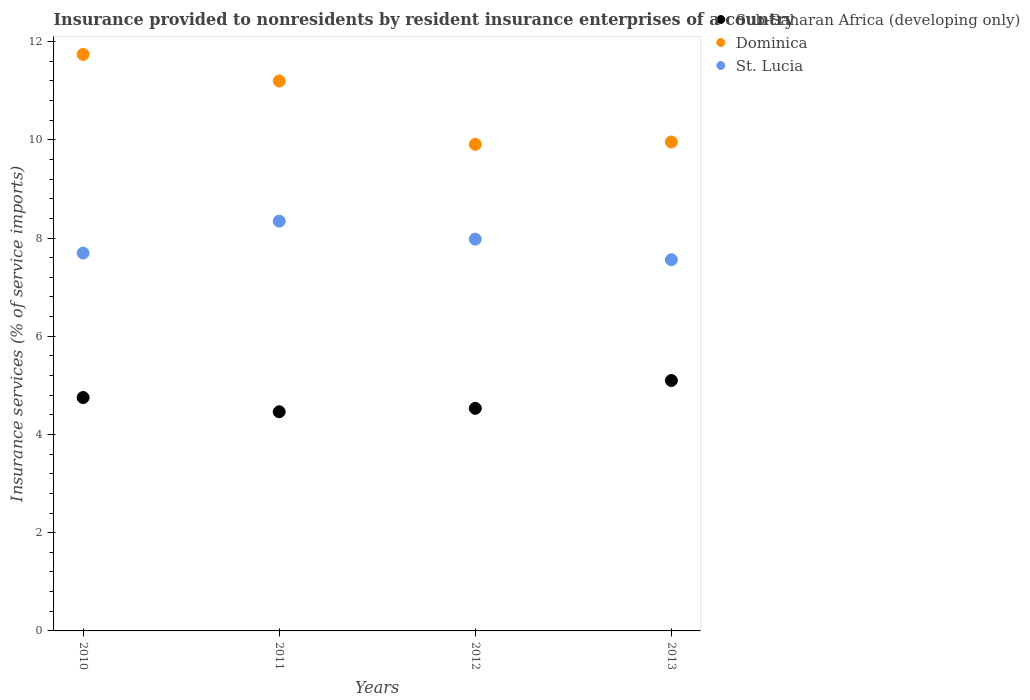How many different coloured dotlines are there?
Offer a terse response. 3. Is the number of dotlines equal to the number of legend labels?
Give a very brief answer. Yes. What is the insurance provided to nonresidents in Dominica in 2010?
Ensure brevity in your answer.  11.74. Across all years, what is the maximum insurance provided to nonresidents in Dominica?
Ensure brevity in your answer.  11.74. Across all years, what is the minimum insurance provided to nonresidents in Sub-Saharan Africa (developing only)?
Keep it short and to the point. 4.46. In which year was the insurance provided to nonresidents in Sub-Saharan Africa (developing only) maximum?
Ensure brevity in your answer.  2013. In which year was the insurance provided to nonresidents in St. Lucia minimum?
Make the answer very short. 2013. What is the total insurance provided to nonresidents in St. Lucia in the graph?
Keep it short and to the point. 31.57. What is the difference between the insurance provided to nonresidents in Dominica in 2011 and that in 2013?
Your answer should be very brief. 1.24. What is the difference between the insurance provided to nonresidents in Sub-Saharan Africa (developing only) in 2011 and the insurance provided to nonresidents in St. Lucia in 2010?
Offer a very short reply. -3.23. What is the average insurance provided to nonresidents in Dominica per year?
Ensure brevity in your answer.  10.7. In the year 2013, what is the difference between the insurance provided to nonresidents in Dominica and insurance provided to nonresidents in Sub-Saharan Africa (developing only)?
Make the answer very short. 4.86. In how many years, is the insurance provided to nonresidents in Dominica greater than 6.8 %?
Your answer should be very brief. 4. What is the ratio of the insurance provided to nonresidents in Dominica in 2012 to that in 2013?
Give a very brief answer. 1. Is the insurance provided to nonresidents in Dominica in 2011 less than that in 2013?
Ensure brevity in your answer.  No. What is the difference between the highest and the second highest insurance provided to nonresidents in Sub-Saharan Africa (developing only)?
Offer a terse response. 0.35. What is the difference between the highest and the lowest insurance provided to nonresidents in Dominica?
Your response must be concise. 1.83. Is the insurance provided to nonresidents in Sub-Saharan Africa (developing only) strictly less than the insurance provided to nonresidents in Dominica over the years?
Offer a very short reply. Yes. What is the difference between two consecutive major ticks on the Y-axis?
Keep it short and to the point. 2. Does the graph contain any zero values?
Provide a short and direct response. No. Does the graph contain grids?
Ensure brevity in your answer.  No. Where does the legend appear in the graph?
Provide a succinct answer. Top right. What is the title of the graph?
Make the answer very short. Insurance provided to nonresidents by resident insurance enterprises of a country. What is the label or title of the Y-axis?
Your answer should be compact. Insurance services (% of service imports). What is the Insurance services (% of service imports) of Sub-Saharan Africa (developing only) in 2010?
Offer a terse response. 4.75. What is the Insurance services (% of service imports) of Dominica in 2010?
Give a very brief answer. 11.74. What is the Insurance services (% of service imports) in St. Lucia in 2010?
Your answer should be very brief. 7.69. What is the Insurance services (% of service imports) of Sub-Saharan Africa (developing only) in 2011?
Offer a very short reply. 4.46. What is the Insurance services (% of service imports) of Dominica in 2011?
Provide a succinct answer. 11.2. What is the Insurance services (% of service imports) in St. Lucia in 2011?
Ensure brevity in your answer.  8.34. What is the Insurance services (% of service imports) in Sub-Saharan Africa (developing only) in 2012?
Provide a succinct answer. 4.53. What is the Insurance services (% of service imports) in Dominica in 2012?
Make the answer very short. 9.91. What is the Insurance services (% of service imports) in St. Lucia in 2012?
Keep it short and to the point. 7.98. What is the Insurance services (% of service imports) of Sub-Saharan Africa (developing only) in 2013?
Your answer should be compact. 5.1. What is the Insurance services (% of service imports) in Dominica in 2013?
Provide a short and direct response. 9.96. What is the Insurance services (% of service imports) of St. Lucia in 2013?
Ensure brevity in your answer.  7.56. Across all years, what is the maximum Insurance services (% of service imports) of Sub-Saharan Africa (developing only)?
Offer a very short reply. 5.1. Across all years, what is the maximum Insurance services (% of service imports) in Dominica?
Your answer should be very brief. 11.74. Across all years, what is the maximum Insurance services (% of service imports) of St. Lucia?
Ensure brevity in your answer.  8.34. Across all years, what is the minimum Insurance services (% of service imports) of Sub-Saharan Africa (developing only)?
Keep it short and to the point. 4.46. Across all years, what is the minimum Insurance services (% of service imports) in Dominica?
Make the answer very short. 9.91. Across all years, what is the minimum Insurance services (% of service imports) of St. Lucia?
Make the answer very short. 7.56. What is the total Insurance services (% of service imports) of Sub-Saharan Africa (developing only) in the graph?
Provide a short and direct response. 18.85. What is the total Insurance services (% of service imports) in Dominica in the graph?
Keep it short and to the point. 42.8. What is the total Insurance services (% of service imports) of St. Lucia in the graph?
Keep it short and to the point. 31.57. What is the difference between the Insurance services (% of service imports) of Sub-Saharan Africa (developing only) in 2010 and that in 2011?
Provide a succinct answer. 0.29. What is the difference between the Insurance services (% of service imports) in Dominica in 2010 and that in 2011?
Offer a terse response. 0.54. What is the difference between the Insurance services (% of service imports) of St. Lucia in 2010 and that in 2011?
Your answer should be compact. -0.65. What is the difference between the Insurance services (% of service imports) of Sub-Saharan Africa (developing only) in 2010 and that in 2012?
Provide a short and direct response. 0.22. What is the difference between the Insurance services (% of service imports) of Dominica in 2010 and that in 2012?
Offer a terse response. 1.83. What is the difference between the Insurance services (% of service imports) in St. Lucia in 2010 and that in 2012?
Provide a short and direct response. -0.28. What is the difference between the Insurance services (% of service imports) in Sub-Saharan Africa (developing only) in 2010 and that in 2013?
Provide a short and direct response. -0.35. What is the difference between the Insurance services (% of service imports) in Dominica in 2010 and that in 2013?
Provide a short and direct response. 1.78. What is the difference between the Insurance services (% of service imports) in St. Lucia in 2010 and that in 2013?
Provide a succinct answer. 0.14. What is the difference between the Insurance services (% of service imports) of Sub-Saharan Africa (developing only) in 2011 and that in 2012?
Make the answer very short. -0.07. What is the difference between the Insurance services (% of service imports) in Dominica in 2011 and that in 2012?
Offer a terse response. 1.29. What is the difference between the Insurance services (% of service imports) of St. Lucia in 2011 and that in 2012?
Provide a succinct answer. 0.37. What is the difference between the Insurance services (% of service imports) of Sub-Saharan Africa (developing only) in 2011 and that in 2013?
Your response must be concise. -0.64. What is the difference between the Insurance services (% of service imports) of Dominica in 2011 and that in 2013?
Offer a terse response. 1.24. What is the difference between the Insurance services (% of service imports) in St. Lucia in 2011 and that in 2013?
Offer a very short reply. 0.79. What is the difference between the Insurance services (% of service imports) in Sub-Saharan Africa (developing only) in 2012 and that in 2013?
Ensure brevity in your answer.  -0.57. What is the difference between the Insurance services (% of service imports) in Dominica in 2012 and that in 2013?
Your response must be concise. -0.05. What is the difference between the Insurance services (% of service imports) in St. Lucia in 2012 and that in 2013?
Offer a terse response. 0.42. What is the difference between the Insurance services (% of service imports) in Sub-Saharan Africa (developing only) in 2010 and the Insurance services (% of service imports) in Dominica in 2011?
Provide a succinct answer. -6.44. What is the difference between the Insurance services (% of service imports) in Sub-Saharan Africa (developing only) in 2010 and the Insurance services (% of service imports) in St. Lucia in 2011?
Offer a very short reply. -3.59. What is the difference between the Insurance services (% of service imports) in Dominica in 2010 and the Insurance services (% of service imports) in St. Lucia in 2011?
Ensure brevity in your answer.  3.39. What is the difference between the Insurance services (% of service imports) of Sub-Saharan Africa (developing only) in 2010 and the Insurance services (% of service imports) of Dominica in 2012?
Your response must be concise. -5.16. What is the difference between the Insurance services (% of service imports) in Sub-Saharan Africa (developing only) in 2010 and the Insurance services (% of service imports) in St. Lucia in 2012?
Offer a very short reply. -3.22. What is the difference between the Insurance services (% of service imports) in Dominica in 2010 and the Insurance services (% of service imports) in St. Lucia in 2012?
Provide a short and direct response. 3.76. What is the difference between the Insurance services (% of service imports) in Sub-Saharan Africa (developing only) in 2010 and the Insurance services (% of service imports) in Dominica in 2013?
Your answer should be very brief. -5.2. What is the difference between the Insurance services (% of service imports) of Sub-Saharan Africa (developing only) in 2010 and the Insurance services (% of service imports) of St. Lucia in 2013?
Your answer should be compact. -2.81. What is the difference between the Insurance services (% of service imports) in Dominica in 2010 and the Insurance services (% of service imports) in St. Lucia in 2013?
Offer a terse response. 4.18. What is the difference between the Insurance services (% of service imports) of Sub-Saharan Africa (developing only) in 2011 and the Insurance services (% of service imports) of Dominica in 2012?
Offer a terse response. -5.45. What is the difference between the Insurance services (% of service imports) in Sub-Saharan Africa (developing only) in 2011 and the Insurance services (% of service imports) in St. Lucia in 2012?
Your response must be concise. -3.51. What is the difference between the Insurance services (% of service imports) in Dominica in 2011 and the Insurance services (% of service imports) in St. Lucia in 2012?
Offer a terse response. 3.22. What is the difference between the Insurance services (% of service imports) in Sub-Saharan Africa (developing only) in 2011 and the Insurance services (% of service imports) in Dominica in 2013?
Make the answer very short. -5.49. What is the difference between the Insurance services (% of service imports) in Sub-Saharan Africa (developing only) in 2011 and the Insurance services (% of service imports) in St. Lucia in 2013?
Your answer should be very brief. -3.1. What is the difference between the Insurance services (% of service imports) in Dominica in 2011 and the Insurance services (% of service imports) in St. Lucia in 2013?
Give a very brief answer. 3.64. What is the difference between the Insurance services (% of service imports) of Sub-Saharan Africa (developing only) in 2012 and the Insurance services (% of service imports) of Dominica in 2013?
Ensure brevity in your answer.  -5.42. What is the difference between the Insurance services (% of service imports) of Sub-Saharan Africa (developing only) in 2012 and the Insurance services (% of service imports) of St. Lucia in 2013?
Provide a short and direct response. -3.03. What is the difference between the Insurance services (% of service imports) in Dominica in 2012 and the Insurance services (% of service imports) in St. Lucia in 2013?
Ensure brevity in your answer.  2.35. What is the average Insurance services (% of service imports) of Sub-Saharan Africa (developing only) per year?
Your answer should be very brief. 4.71. What is the average Insurance services (% of service imports) of Dominica per year?
Your answer should be compact. 10.7. What is the average Insurance services (% of service imports) of St. Lucia per year?
Ensure brevity in your answer.  7.89. In the year 2010, what is the difference between the Insurance services (% of service imports) in Sub-Saharan Africa (developing only) and Insurance services (% of service imports) in Dominica?
Provide a short and direct response. -6.99. In the year 2010, what is the difference between the Insurance services (% of service imports) of Sub-Saharan Africa (developing only) and Insurance services (% of service imports) of St. Lucia?
Keep it short and to the point. -2.94. In the year 2010, what is the difference between the Insurance services (% of service imports) in Dominica and Insurance services (% of service imports) in St. Lucia?
Your answer should be compact. 4.04. In the year 2011, what is the difference between the Insurance services (% of service imports) of Sub-Saharan Africa (developing only) and Insurance services (% of service imports) of Dominica?
Give a very brief answer. -6.73. In the year 2011, what is the difference between the Insurance services (% of service imports) of Sub-Saharan Africa (developing only) and Insurance services (% of service imports) of St. Lucia?
Your response must be concise. -3.88. In the year 2011, what is the difference between the Insurance services (% of service imports) of Dominica and Insurance services (% of service imports) of St. Lucia?
Keep it short and to the point. 2.85. In the year 2012, what is the difference between the Insurance services (% of service imports) of Sub-Saharan Africa (developing only) and Insurance services (% of service imports) of Dominica?
Give a very brief answer. -5.38. In the year 2012, what is the difference between the Insurance services (% of service imports) in Sub-Saharan Africa (developing only) and Insurance services (% of service imports) in St. Lucia?
Give a very brief answer. -3.44. In the year 2012, what is the difference between the Insurance services (% of service imports) in Dominica and Insurance services (% of service imports) in St. Lucia?
Make the answer very short. 1.93. In the year 2013, what is the difference between the Insurance services (% of service imports) of Sub-Saharan Africa (developing only) and Insurance services (% of service imports) of Dominica?
Provide a short and direct response. -4.86. In the year 2013, what is the difference between the Insurance services (% of service imports) in Sub-Saharan Africa (developing only) and Insurance services (% of service imports) in St. Lucia?
Make the answer very short. -2.46. In the year 2013, what is the difference between the Insurance services (% of service imports) in Dominica and Insurance services (% of service imports) in St. Lucia?
Provide a succinct answer. 2.4. What is the ratio of the Insurance services (% of service imports) of Sub-Saharan Africa (developing only) in 2010 to that in 2011?
Make the answer very short. 1.06. What is the ratio of the Insurance services (% of service imports) of Dominica in 2010 to that in 2011?
Your answer should be compact. 1.05. What is the ratio of the Insurance services (% of service imports) in St. Lucia in 2010 to that in 2011?
Provide a short and direct response. 0.92. What is the ratio of the Insurance services (% of service imports) in Sub-Saharan Africa (developing only) in 2010 to that in 2012?
Keep it short and to the point. 1.05. What is the ratio of the Insurance services (% of service imports) in Dominica in 2010 to that in 2012?
Offer a very short reply. 1.18. What is the ratio of the Insurance services (% of service imports) in St. Lucia in 2010 to that in 2012?
Keep it short and to the point. 0.96. What is the ratio of the Insurance services (% of service imports) of Sub-Saharan Africa (developing only) in 2010 to that in 2013?
Your response must be concise. 0.93. What is the ratio of the Insurance services (% of service imports) of Dominica in 2010 to that in 2013?
Make the answer very short. 1.18. What is the ratio of the Insurance services (% of service imports) of St. Lucia in 2010 to that in 2013?
Make the answer very short. 1.02. What is the ratio of the Insurance services (% of service imports) of Sub-Saharan Africa (developing only) in 2011 to that in 2012?
Your answer should be compact. 0.98. What is the ratio of the Insurance services (% of service imports) in Dominica in 2011 to that in 2012?
Keep it short and to the point. 1.13. What is the ratio of the Insurance services (% of service imports) of St. Lucia in 2011 to that in 2012?
Your response must be concise. 1.05. What is the ratio of the Insurance services (% of service imports) in Sub-Saharan Africa (developing only) in 2011 to that in 2013?
Offer a very short reply. 0.88. What is the ratio of the Insurance services (% of service imports) of Dominica in 2011 to that in 2013?
Your answer should be compact. 1.12. What is the ratio of the Insurance services (% of service imports) of St. Lucia in 2011 to that in 2013?
Keep it short and to the point. 1.1. What is the ratio of the Insurance services (% of service imports) in Sub-Saharan Africa (developing only) in 2012 to that in 2013?
Keep it short and to the point. 0.89. What is the ratio of the Insurance services (% of service imports) in Dominica in 2012 to that in 2013?
Offer a terse response. 1. What is the ratio of the Insurance services (% of service imports) in St. Lucia in 2012 to that in 2013?
Make the answer very short. 1.06. What is the difference between the highest and the second highest Insurance services (% of service imports) of Sub-Saharan Africa (developing only)?
Give a very brief answer. 0.35. What is the difference between the highest and the second highest Insurance services (% of service imports) in Dominica?
Ensure brevity in your answer.  0.54. What is the difference between the highest and the second highest Insurance services (% of service imports) in St. Lucia?
Your response must be concise. 0.37. What is the difference between the highest and the lowest Insurance services (% of service imports) of Sub-Saharan Africa (developing only)?
Your answer should be compact. 0.64. What is the difference between the highest and the lowest Insurance services (% of service imports) of Dominica?
Your answer should be very brief. 1.83. What is the difference between the highest and the lowest Insurance services (% of service imports) in St. Lucia?
Provide a short and direct response. 0.79. 